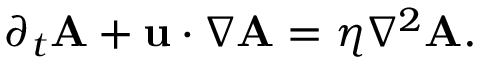<formula> <loc_0><loc_0><loc_500><loc_500>\begin{array} { r } { \partial _ { t } A + u \cdot \nabla A = \eta \nabla ^ { 2 } A . } \end{array}</formula> 